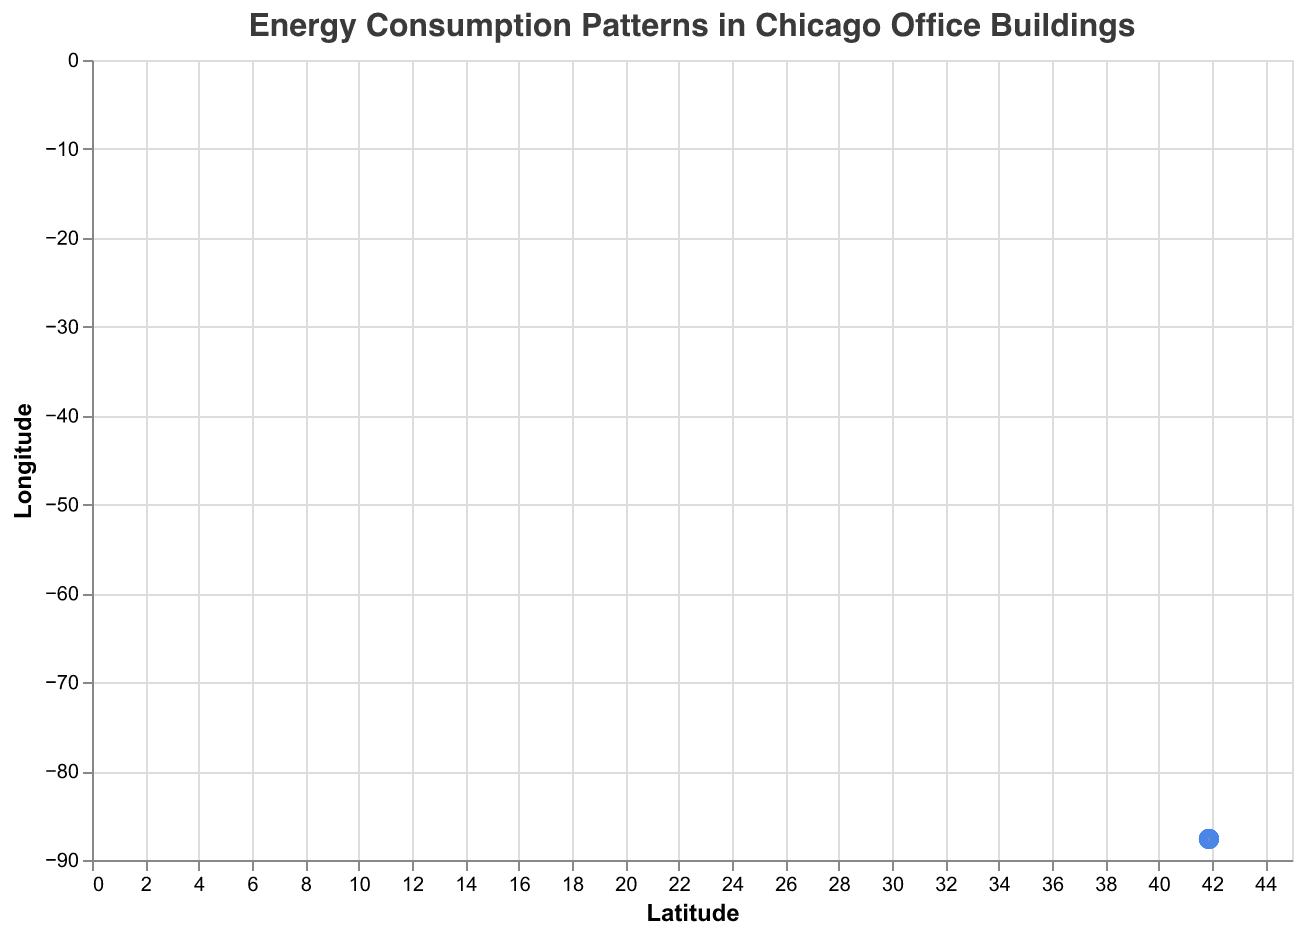What is the title of the figure? The title is usually prominently displayed at the top center of the figure. Here, it is "Energy Consumption Patterns in Chicago Office Buildings".
Answer: Energy Consumption Patterns in Chicago Office Buildings Which building has the highest vertical energy consumption component? The length of the arrows represents the energy consumption component. The building with the arrow pointing the highest vertically (v-component) is "Trump International Hotel and Tower" with v = 3.5.
Answer: Trump International Hotel and Tower What are the latitude and longitude ranges for the data points in the plot? To determine the latitude and longitude ranges, we observe the x (latitude) and y (longitude) axes. The lowest latitude is 41.8781, and the highest is 41.8902. The lowest longitude is -87.6354, and the highest is -87.6205.
Answer: Latitude: 41.8781 to 41.8902, Longitude: -87.6354 to -87.6205 Which building has the smallest horizontal energy consumption component? By looking at the arrows and their u-components, the building with the smallest horizontal component (most negative u) is "Aon Center" with u = -3.1.
Answer: Aon Center How many office buildings are represented in the plot? To find the number of data points, we count the number of buildings listed in the data: Willis Tower, Merchandise Mart, Aon Center, Trump International Hotel and Tower, One Prudential Plaza, 222 North LaSalle, River Point, Blue Cross Blue Shield Tower, 150 North Riverside, 300 North LaSalle.
Answer: 10 What are the u and v components for the building located at latitude 41.8781 and longitude -87.6298? The building located at these coordinates is "Willis Tower." Referring to the data, the u and v components are u = -2.5 and v = 3.2.
Answer: u = -2.5, v = 3.2 Which building has the closest horizontal and vertical energy consumption components? By comparing the u and v values for each building, "One Prudential Plaza" has u = -1.9 and v = 3.0, which are numerically close to each other.
Answer: One Prudential Plaza Which building is positioned furthest north? The building with the highest latitude value is the furthest north. "Trump International Hotel and Tower" at latitude 41.8902 is the highest.
Answer: Trump International Hotel and Tower Comparing "Willis Tower" and "Aon Center," which has a greater vertical energy consumption component? The vertical components (v) for "Willis Tower" and "Aon Center" are 3.2 and 2.9, respectively. Therefore, "Willis Tower" has a greater vertical energy consumption.
Answer: Willis Tower 